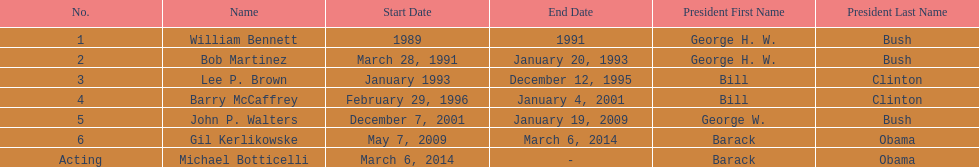How long did lee p. brown serve for? 2 years. 